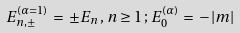Convert formula to latex. <formula><loc_0><loc_0><loc_500><loc_500>E ^ { ( \alpha = 1 ) } _ { n , \pm } \, = \, \pm E _ { n } \, , \, n \geq 1 \, ; \, E ^ { ( \alpha ) } _ { 0 } \, = \, - \, | m |</formula> 